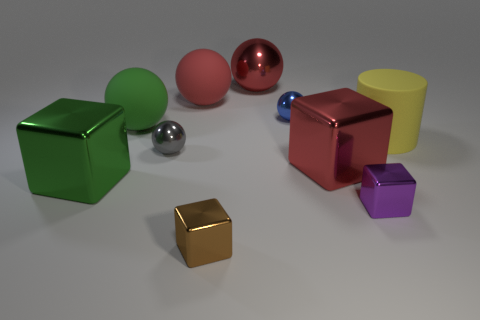How big is the red metallic thing that is behind the large green sphere?
Provide a succinct answer. Large. Is the material of the cylinder the same as the tiny blue thing?
Your answer should be very brief. No. Is there a tiny blue shiny object that is to the right of the tiny sphere that is on the right side of the metallic thing that is in front of the purple object?
Offer a very short reply. No. What is the color of the matte cylinder?
Your answer should be very brief. Yellow. What is the color of the metallic cube that is the same size as the brown thing?
Make the answer very short. Purple. There is a rubber thing behind the tiny blue shiny sphere; does it have the same shape as the tiny gray shiny object?
Provide a succinct answer. Yes. What color is the small cube that is on the right side of the big cube right of the rubber ball that is left of the small gray metallic ball?
Give a very brief answer. Purple. Is there a big yellow matte thing?
Your answer should be very brief. Yes. How many other objects are there of the same size as the red metallic cube?
Provide a succinct answer. 5. Is the color of the cylinder the same as the large rubber object left of the tiny gray ball?
Give a very brief answer. No. 